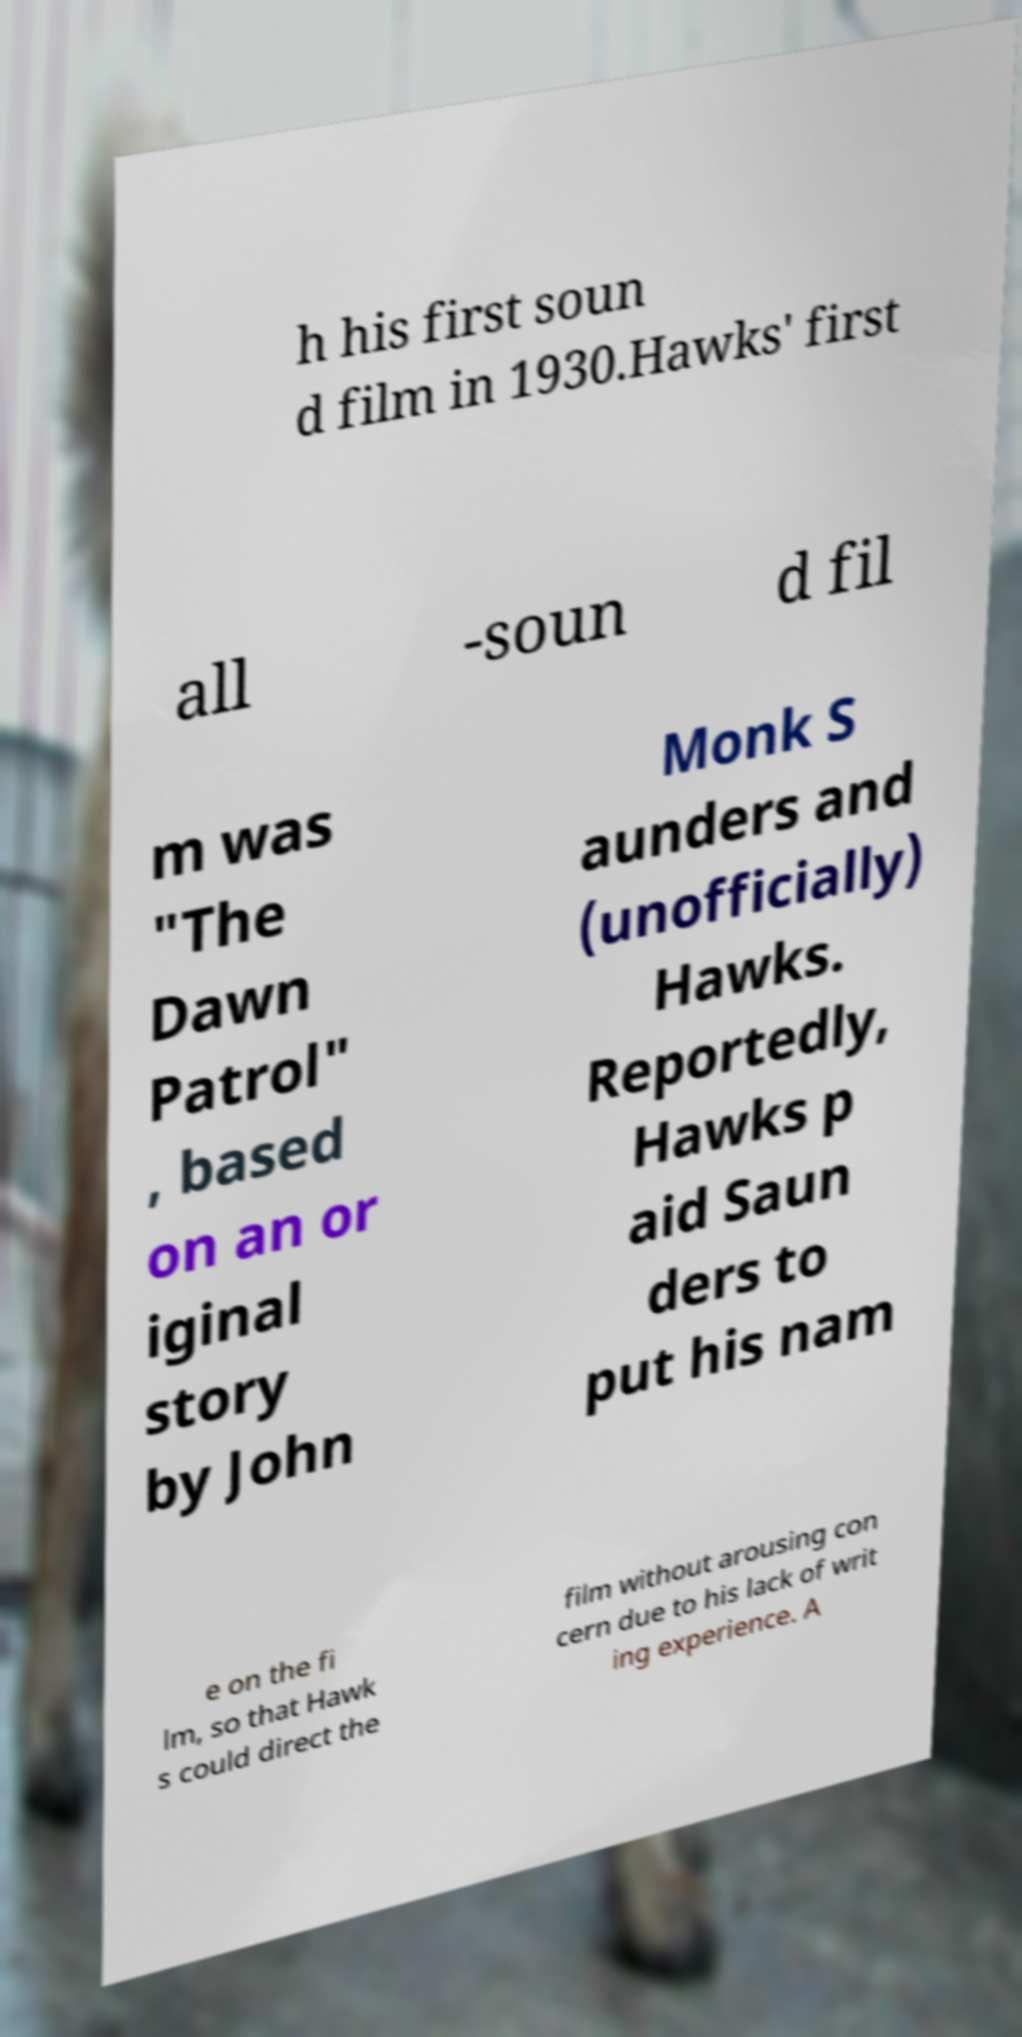There's text embedded in this image that I need extracted. Can you transcribe it verbatim? h his first soun d film in 1930.Hawks' first all -soun d fil m was "The Dawn Patrol" , based on an or iginal story by John Monk S aunders and (unofficially) Hawks. Reportedly, Hawks p aid Saun ders to put his nam e on the fi lm, so that Hawk s could direct the film without arousing con cern due to his lack of writ ing experience. A 